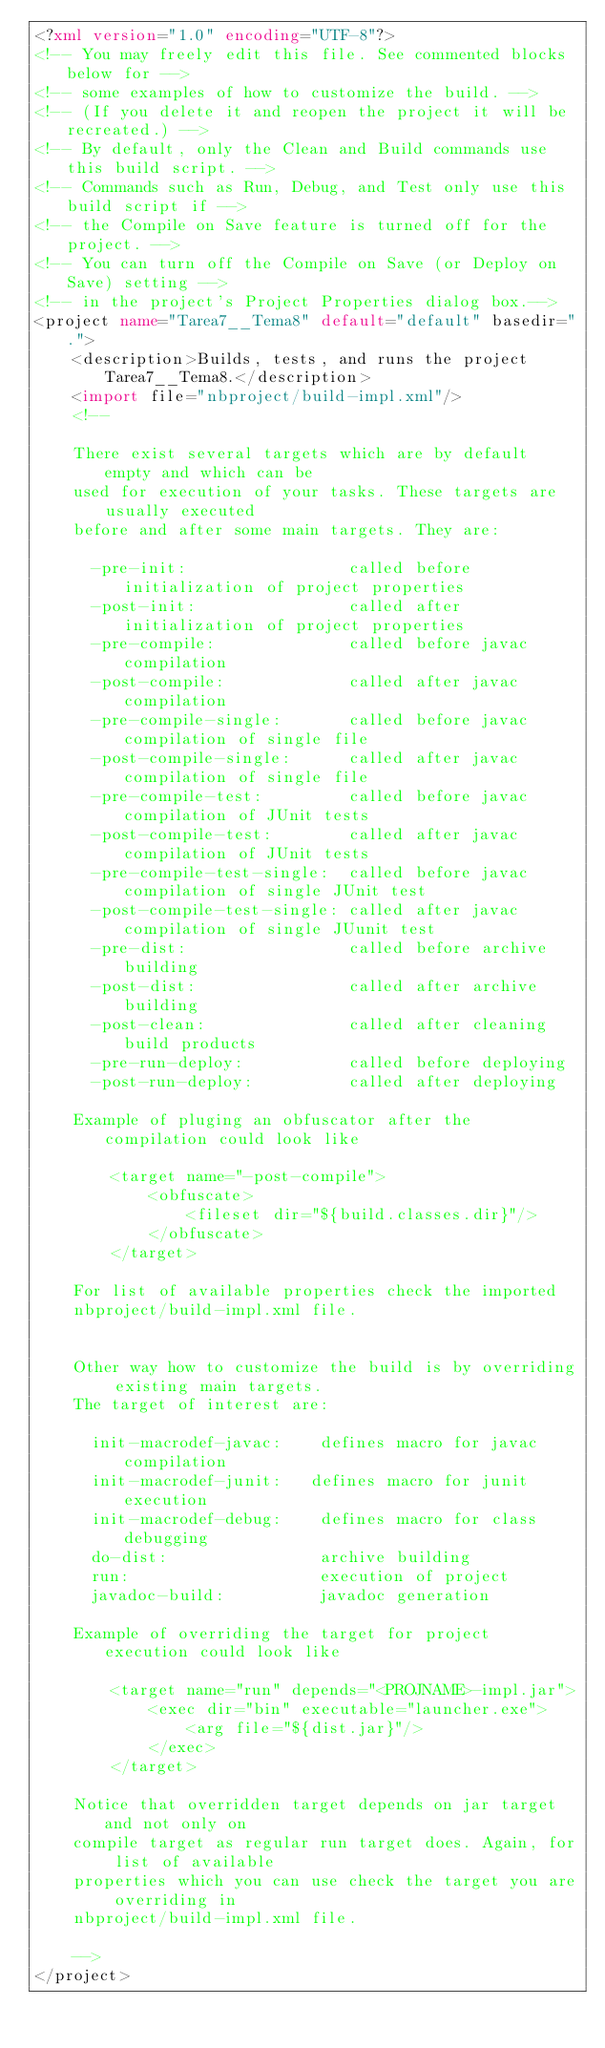Convert code to text. <code><loc_0><loc_0><loc_500><loc_500><_XML_><?xml version="1.0" encoding="UTF-8"?>
<!-- You may freely edit this file. See commented blocks below for -->
<!-- some examples of how to customize the build. -->
<!-- (If you delete it and reopen the project it will be recreated.) -->
<!-- By default, only the Clean and Build commands use this build script. -->
<!-- Commands such as Run, Debug, and Test only use this build script if -->
<!-- the Compile on Save feature is turned off for the project. -->
<!-- You can turn off the Compile on Save (or Deploy on Save) setting -->
<!-- in the project's Project Properties dialog box.-->
<project name="Tarea7__Tema8" default="default" basedir=".">
    <description>Builds, tests, and runs the project Tarea7__Tema8.</description>
    <import file="nbproject/build-impl.xml"/>
    <!--

    There exist several targets which are by default empty and which can be 
    used for execution of your tasks. These targets are usually executed 
    before and after some main targets. They are: 

      -pre-init:                 called before initialization of project properties 
      -post-init:                called after initialization of project properties 
      -pre-compile:              called before javac compilation 
      -post-compile:             called after javac compilation 
      -pre-compile-single:       called before javac compilation of single file
      -post-compile-single:      called after javac compilation of single file
      -pre-compile-test:         called before javac compilation of JUnit tests
      -post-compile-test:        called after javac compilation of JUnit tests
      -pre-compile-test-single:  called before javac compilation of single JUnit test
      -post-compile-test-single: called after javac compilation of single JUunit test
      -pre-dist:                 called before archive building 
      -post-dist:                called after archive building 
      -post-clean:               called after cleaning build products 
      -pre-run-deploy:           called before deploying
      -post-run-deploy:          called after deploying

    Example of pluging an obfuscator after the compilation could look like 

        <target name="-post-compile">
            <obfuscate>
                <fileset dir="${build.classes.dir}"/>
            </obfuscate>
        </target>

    For list of available properties check the imported 
    nbproject/build-impl.xml file. 


    Other way how to customize the build is by overriding existing main targets.
    The target of interest are: 

      init-macrodef-javac:    defines macro for javac compilation
      init-macrodef-junit:   defines macro for junit execution
      init-macrodef-debug:    defines macro for class debugging
      do-dist:                archive building
      run:                    execution of project 
      javadoc-build:          javadoc generation 

    Example of overriding the target for project execution could look like 

        <target name="run" depends="<PROJNAME>-impl.jar">
            <exec dir="bin" executable="launcher.exe">
                <arg file="${dist.jar}"/>
            </exec>
        </target>

    Notice that overridden target depends on jar target and not only on 
    compile target as regular run target does. Again, for list of available 
    properties which you can use check the target you are overriding in 
    nbproject/build-impl.xml file. 

    -->
</project>
</code> 